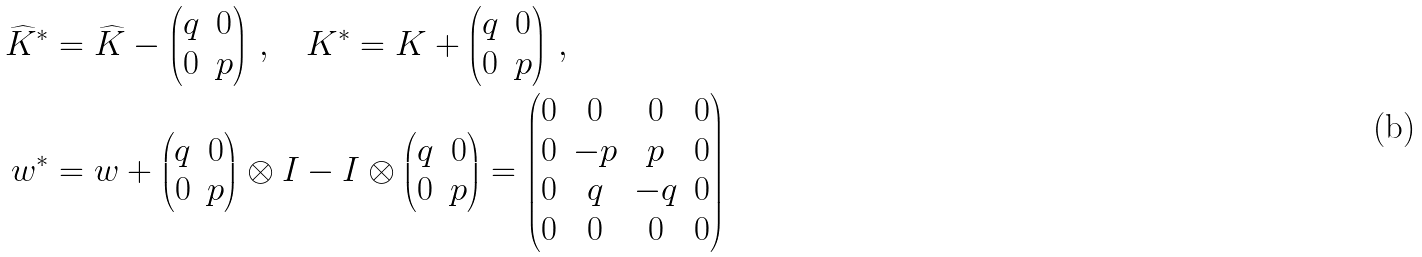<formula> <loc_0><loc_0><loc_500><loc_500>\widehat { K } ^ { * } & = \widehat { K } - \begin{pmatrix} q & 0 \\ 0 & p \end{pmatrix} \, , \quad K ^ { * } = K + \begin{pmatrix} q & 0 \\ 0 & p \end{pmatrix} \, , \\ w ^ { * } & = w + \begin{pmatrix} q & 0 \\ 0 & p \end{pmatrix} \otimes I - I \otimes \begin{pmatrix} q & 0 \\ 0 & p \end{pmatrix} = \begin{pmatrix} 0 & 0 & 0 & 0 \\ 0 & - p & p & 0 \\ 0 & q & - q & 0 \\ 0 & 0 & 0 & 0 \end{pmatrix}</formula> 